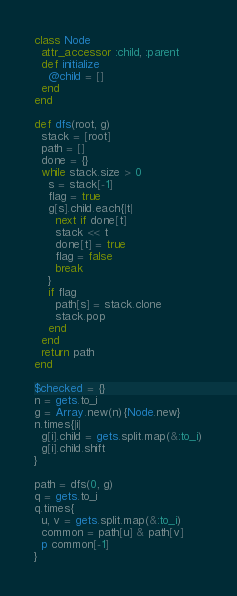<code> <loc_0><loc_0><loc_500><loc_500><_Ruby_>class Node
  attr_accessor :child, :parent
  def initialize
    @child = []
  end
end

def dfs(root, g)
  stack = [root]
  path = []
  done = {}
  while stack.size > 0
    s = stack[-1]
    flag = true
    g[s].child.each{|t|
      next if done[t]
      stack << t
      done[t] = true
      flag = false
      break
    }
    if flag
      path[s] = stack.clone
      stack.pop
    end
  end
  return path
end

$checked = {}
n = gets.to_i
g = Array.new(n){Node.new}
n.times{|i|
  g[i].child = gets.split.map(&:to_i)
  g[i].child.shift
}

path = dfs(0, g)
q = gets.to_i
q.times{
  u, v = gets.split.map(&:to_i)
  common = path[u] & path[v]
  p common[-1]
}</code> 